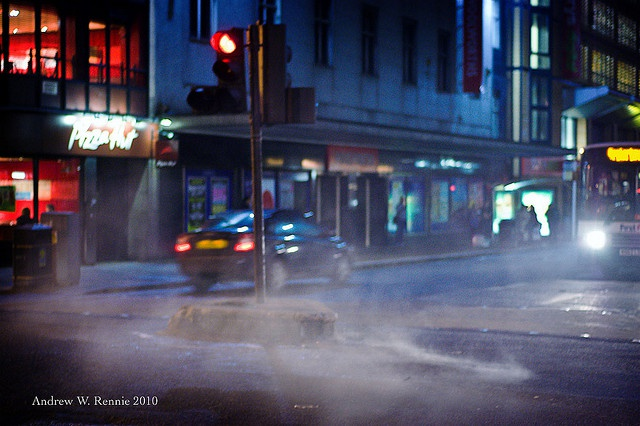Describe the objects in this image and their specific colors. I can see car in black, gray, and navy tones, bus in black, gray, and navy tones, traffic light in black, red, navy, and ivory tones, traffic light in black, navy, and maroon tones, and people in black, navy, maroon, and red tones in this image. 